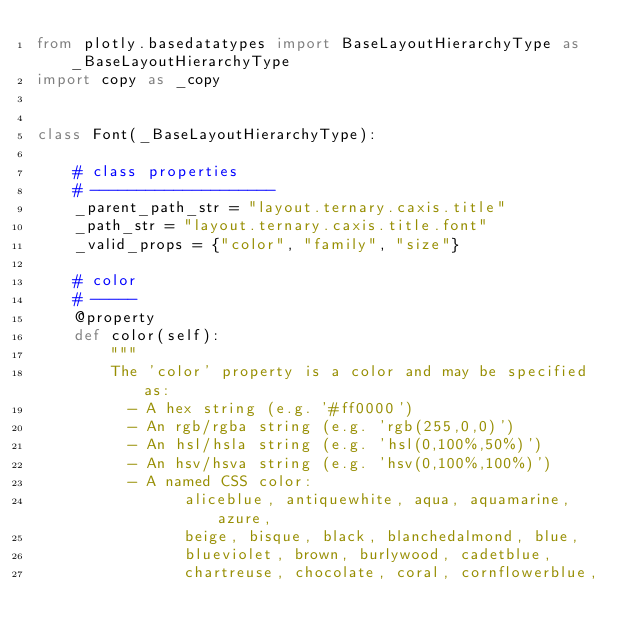Convert code to text. <code><loc_0><loc_0><loc_500><loc_500><_Python_>from plotly.basedatatypes import BaseLayoutHierarchyType as _BaseLayoutHierarchyType
import copy as _copy


class Font(_BaseLayoutHierarchyType):

    # class properties
    # --------------------
    _parent_path_str = "layout.ternary.caxis.title"
    _path_str = "layout.ternary.caxis.title.font"
    _valid_props = {"color", "family", "size"}

    # color
    # -----
    @property
    def color(self):
        """
        The 'color' property is a color and may be specified as:
          - A hex string (e.g. '#ff0000')
          - An rgb/rgba string (e.g. 'rgb(255,0,0)')
          - An hsl/hsla string (e.g. 'hsl(0,100%,50%)')
          - An hsv/hsva string (e.g. 'hsv(0,100%,100%)')
          - A named CSS color:
                aliceblue, antiquewhite, aqua, aquamarine, azure,
                beige, bisque, black, blanchedalmond, blue,
                blueviolet, brown, burlywood, cadetblue,
                chartreuse, chocolate, coral, cornflowerblue,</code> 